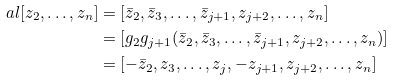Convert formula to latex. <formula><loc_0><loc_0><loc_500><loc_500>\ a l [ z _ { 2 } , \dots , z _ { n } ] & = [ \bar { z } _ { 2 } , \bar { z } _ { 3 } , \dots , \bar { z } _ { j + 1 } , z _ { j + 2 } , \dots , z _ { n } ] \\ & = [ g _ { 2 } g _ { j + 1 } ( \bar { z } _ { 2 } , \bar { z } _ { 3 } , \dots , \bar { z } _ { j + 1 } , z _ { j + 2 } , \dots , z _ { n } ) ] \\ & = [ - \bar { z } _ { 2 } , z _ { 3 } , \dots , z _ { j } , - z _ { j + 1 } , z _ { j + 2 } , \dots , z _ { n } ]</formula> 